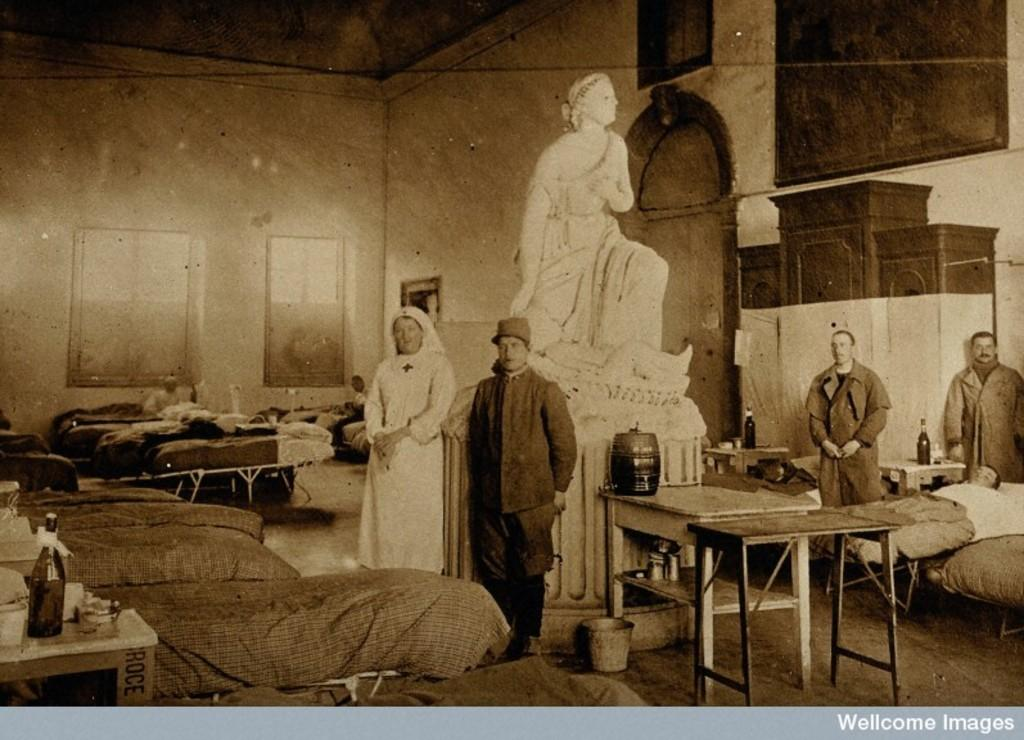How many people are in the image? A: There are three men and a woman in the image, making a total of four people. Where is the woman positioned in the image? The woman is standing on the left side. What type of furniture can be seen in the image? There are beds in the image. What object is on the table in the image? There is a bottle on a table. What can be seen in the background of the image? There is a statue, a wall, and a window in the background. What type of shelf can be seen in the image? There is no shelf present in the image. How does the woman's throat look in the image? The image does not show the woman's throat, so it cannot be described. 